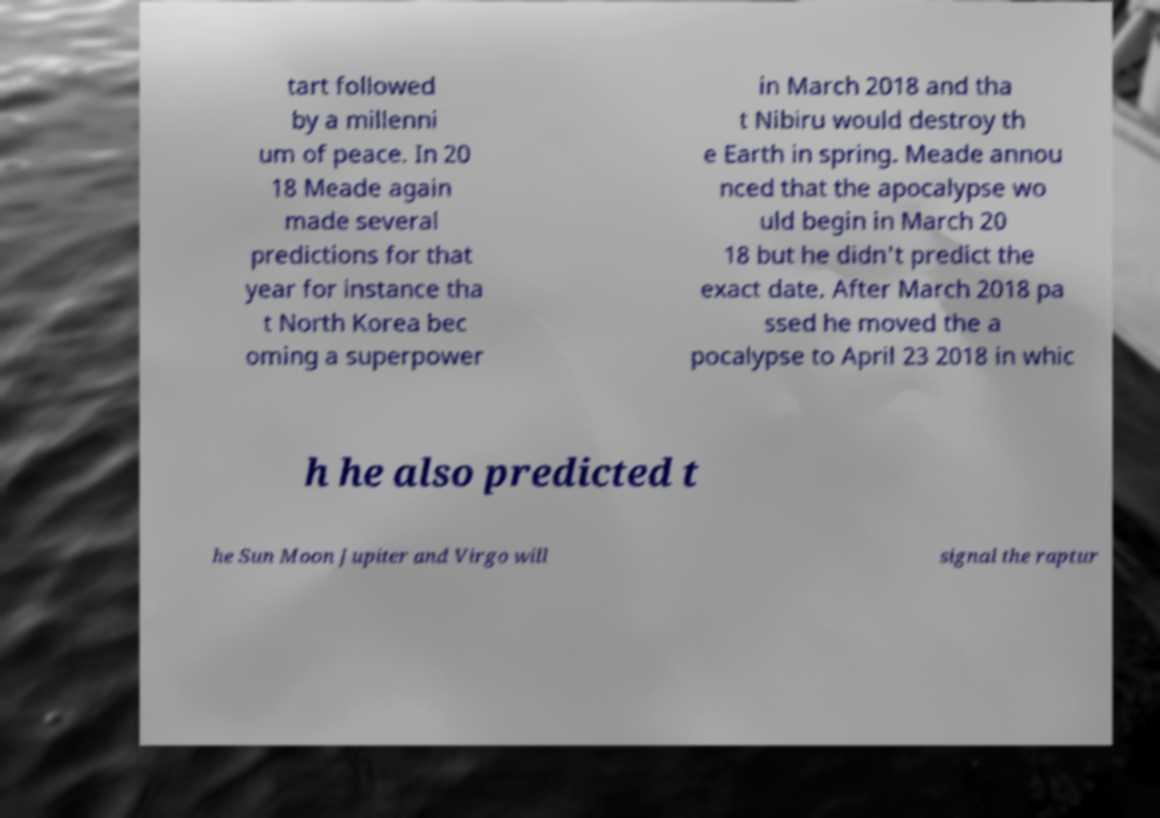Please identify and transcribe the text found in this image. tart followed by a millenni um of peace. In 20 18 Meade again made several predictions for that year for instance tha t North Korea bec oming a superpower in March 2018 and tha t Nibiru would destroy th e Earth in spring. Meade annou nced that the apocalypse wo uld begin in March 20 18 but he didn't predict the exact date. After March 2018 pa ssed he moved the a pocalypse to April 23 2018 in whic h he also predicted t he Sun Moon Jupiter and Virgo will signal the raptur 